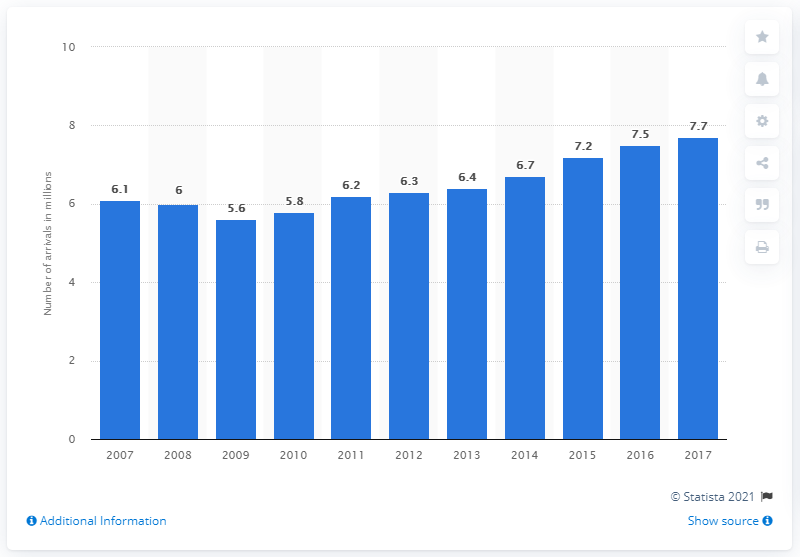Draw attention to some important aspects in this diagram. In 2017, 7.7 million tourists arrived at accommodation establishments in Denmark. 